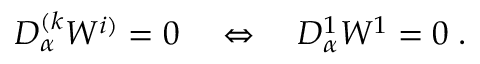<formula> <loc_0><loc_0><loc_500><loc_500>D _ { \alpha } ^ { ( k } W ^ { i ) } = 0 \quad \Leftrightarrow \quad D _ { \alpha } ^ { 1 } W ^ { 1 } = 0 \, .</formula> 